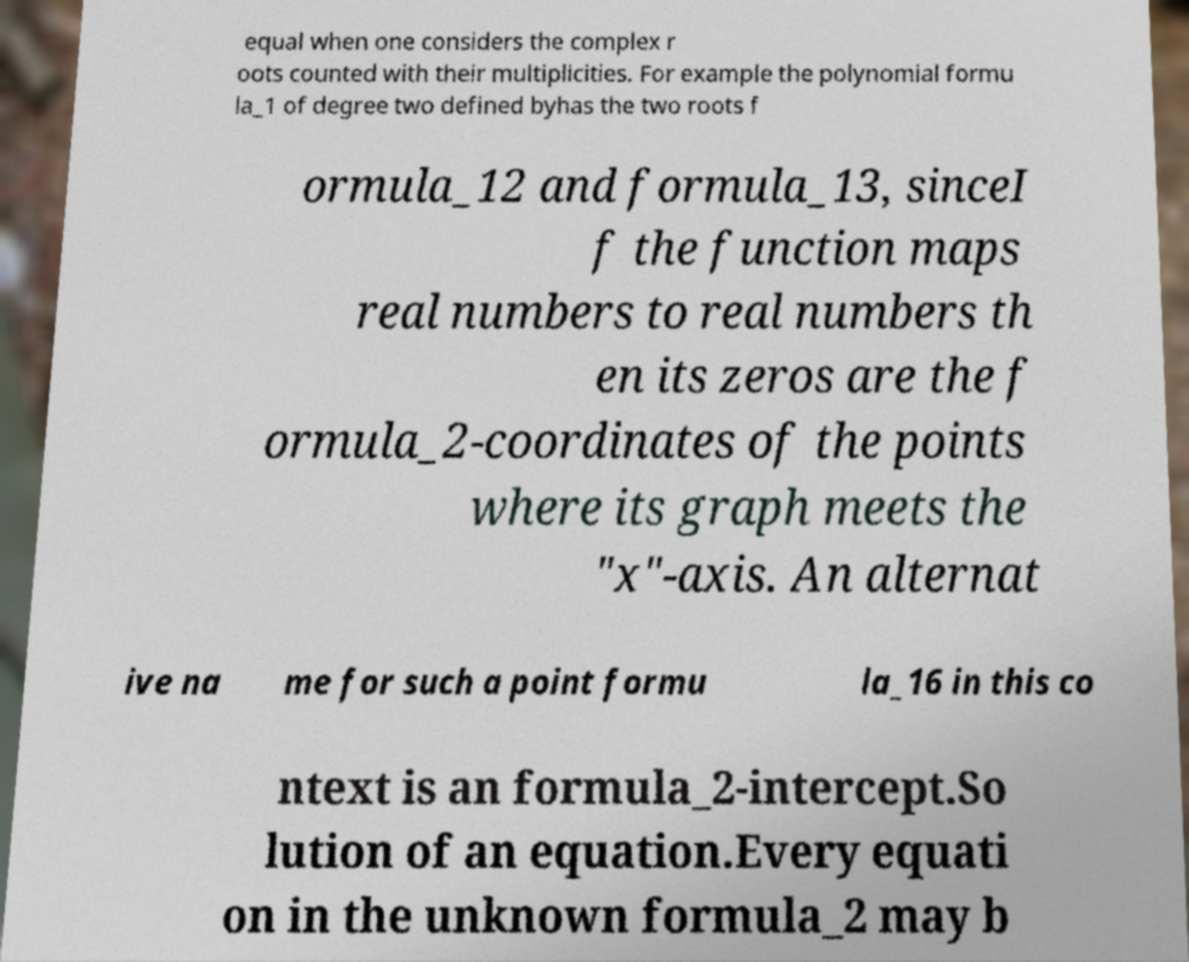There's text embedded in this image that I need extracted. Can you transcribe it verbatim? equal when one considers the complex r oots counted with their multiplicities. For example the polynomial formu la_1 of degree two defined byhas the two roots f ormula_12 and formula_13, sinceI f the function maps real numbers to real numbers th en its zeros are the f ormula_2-coordinates of the points where its graph meets the "x"-axis. An alternat ive na me for such a point formu la_16 in this co ntext is an formula_2-intercept.So lution of an equation.Every equati on in the unknown formula_2 may b 